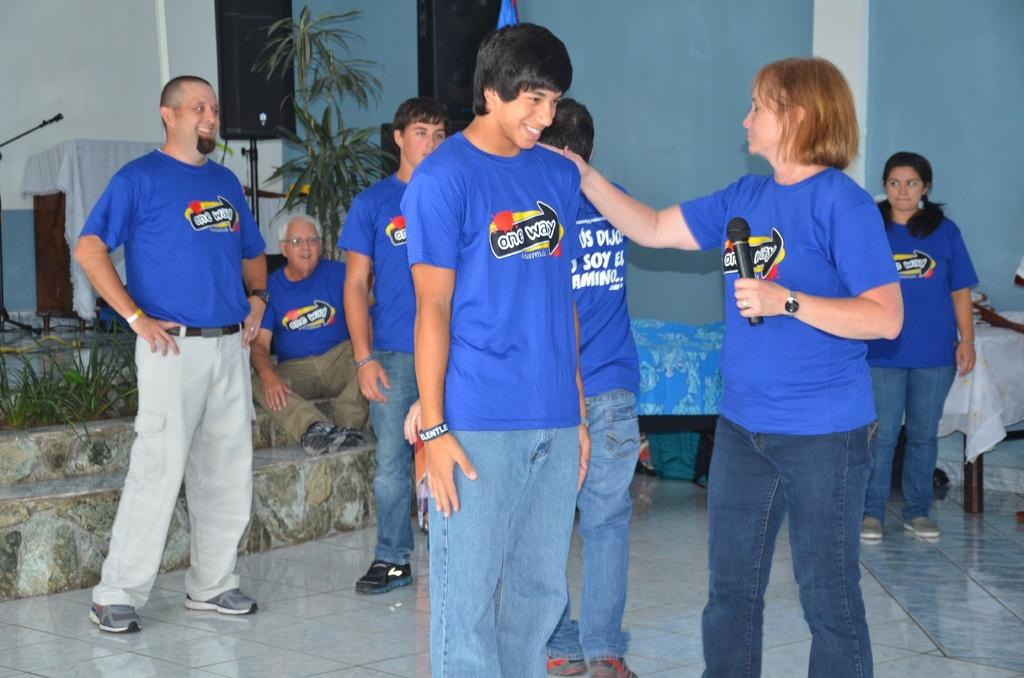<image>
Give a short and clear explanation of the subsequent image. People on stage are wearing blue t shirts that say "one way." 